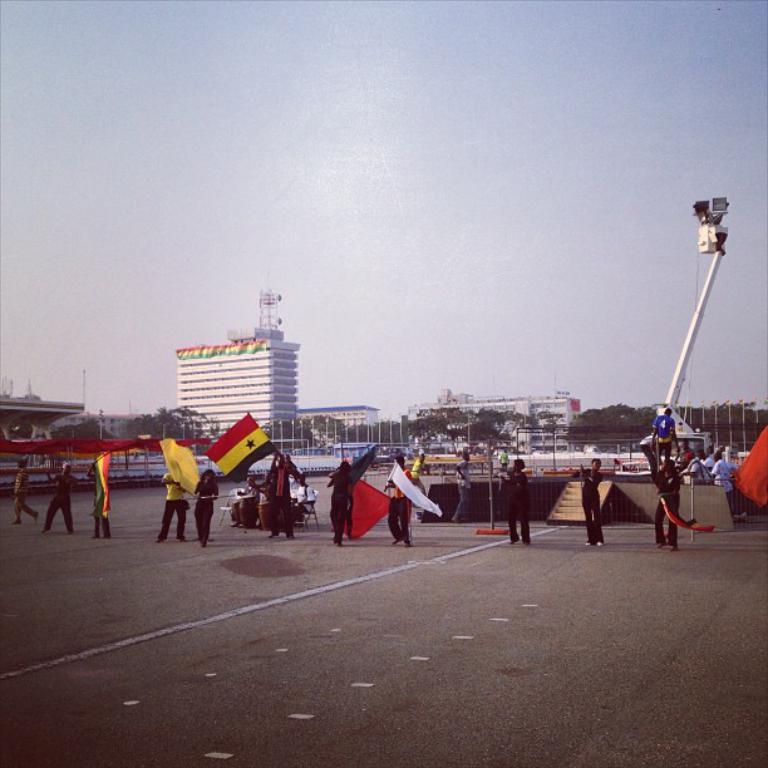Describe this image in one or two sentences. In the picture I can see people are standing on the ground among them some are holding flags in hands. In the background I can see buildings, the sky, trees, poles and some other objects. 